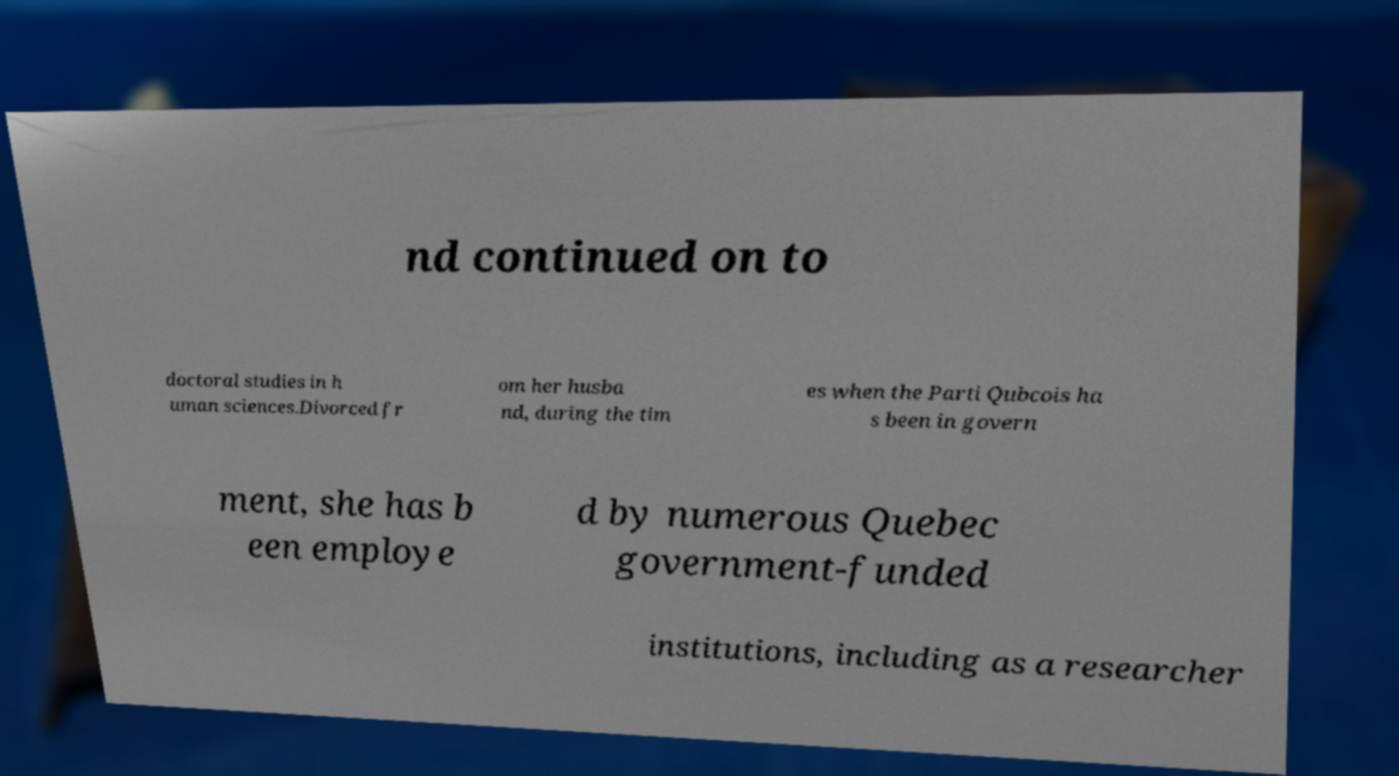Can you accurately transcribe the text from the provided image for me? nd continued on to doctoral studies in h uman sciences.Divorced fr om her husba nd, during the tim es when the Parti Qubcois ha s been in govern ment, she has b een employe d by numerous Quebec government-funded institutions, including as a researcher 